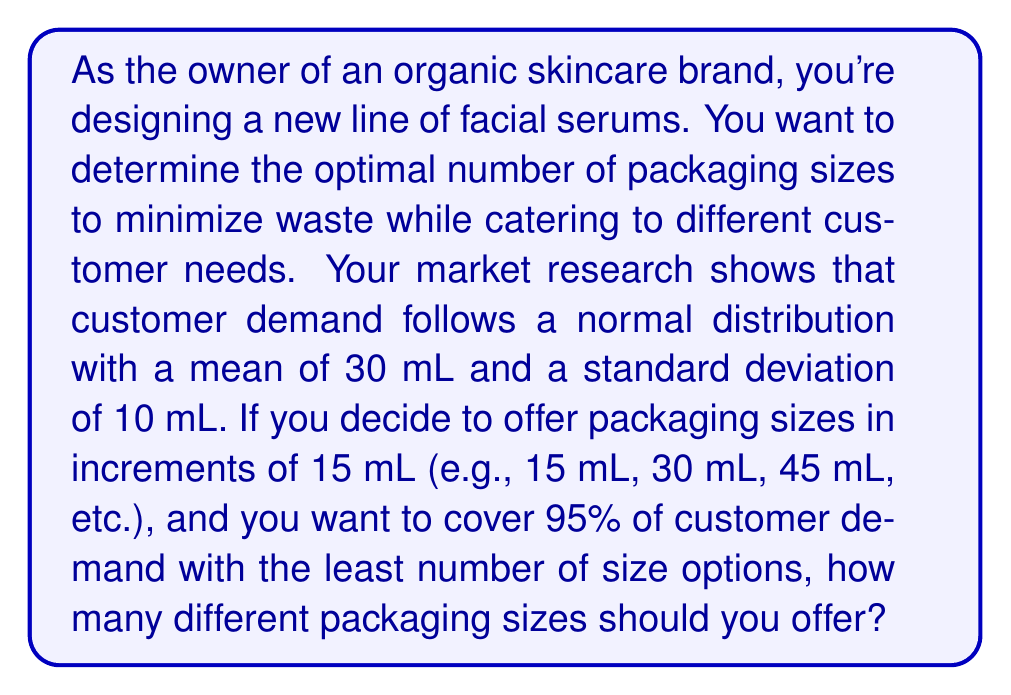Provide a solution to this math problem. To solve this problem, we need to follow these steps:

1. Understand the normal distribution of customer demand:
   - Mean (μ) = 30 mL
   - Standard deviation (σ) = 10 mL

2. Determine the range that covers 95% of the distribution:
   In a normal distribution, approximately 95% of the data falls within 2 standard deviations of the mean.
   
   Lower bound: $μ - 2σ = 30 - 2(10) = 10$ mL
   Upper bound: $μ + 2σ = 30 + 2(10) = 50$ mL

3. Calculate the number of 15 mL increments needed to cover this range:
   
   Range = Upper bound - Lower bound = 50 - 10 = 40 mL
   
   Number of increments = $\left\lceil\frac{\text{Range}}{\text{Increment size}}\right\rceil = \left\lceil\frac{40}{15}\right\rceil = \left\lceil2.67\right\rceil = 3$

4. Determine the actual packaging sizes:
   - 15 mL (covers 0-22.5 mL)
   - 30 mL (covers 22.5-37.5 mL)
   - 45 mL (covers 37.5-52.5 mL)

These three sizes cover the range from 0 to 52.5 mL, which encompasses the required range of 10 to 50 mL.
Answer: 3 packaging sizes 